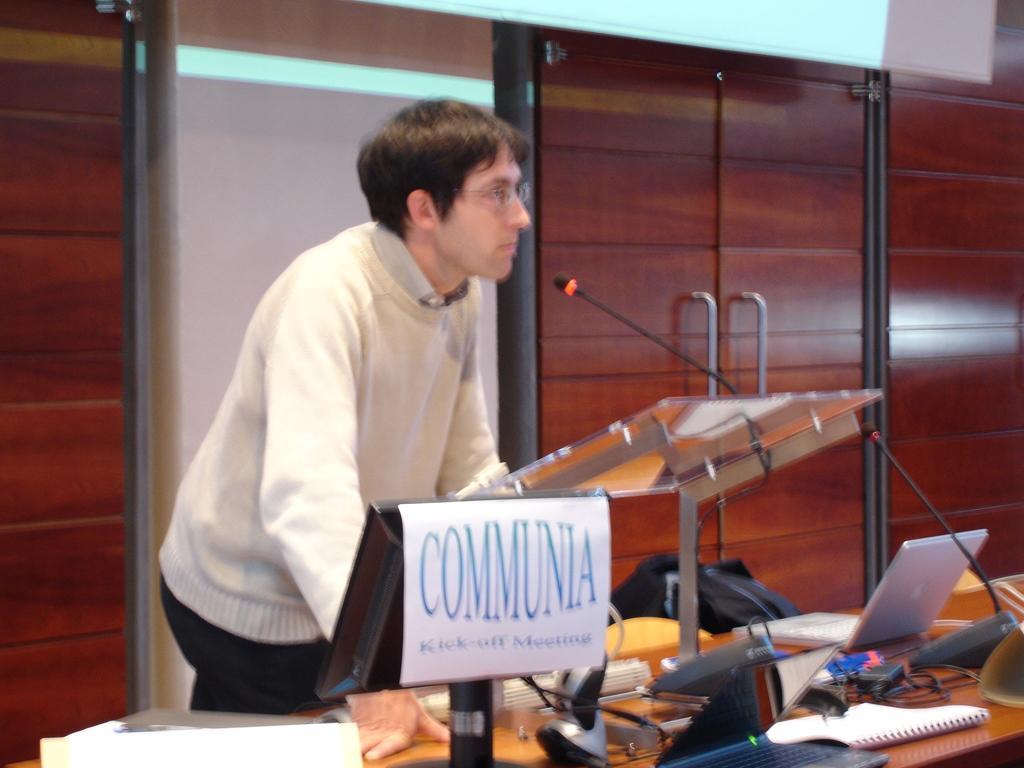Can you describe this image briefly? In the image we can see a man wearing clothes and spectacles. In front of him we can see a microphone and the desk, on the desk there are many other objects, cable wires and a book. Behind him we can see a window and wooden cupboards. 